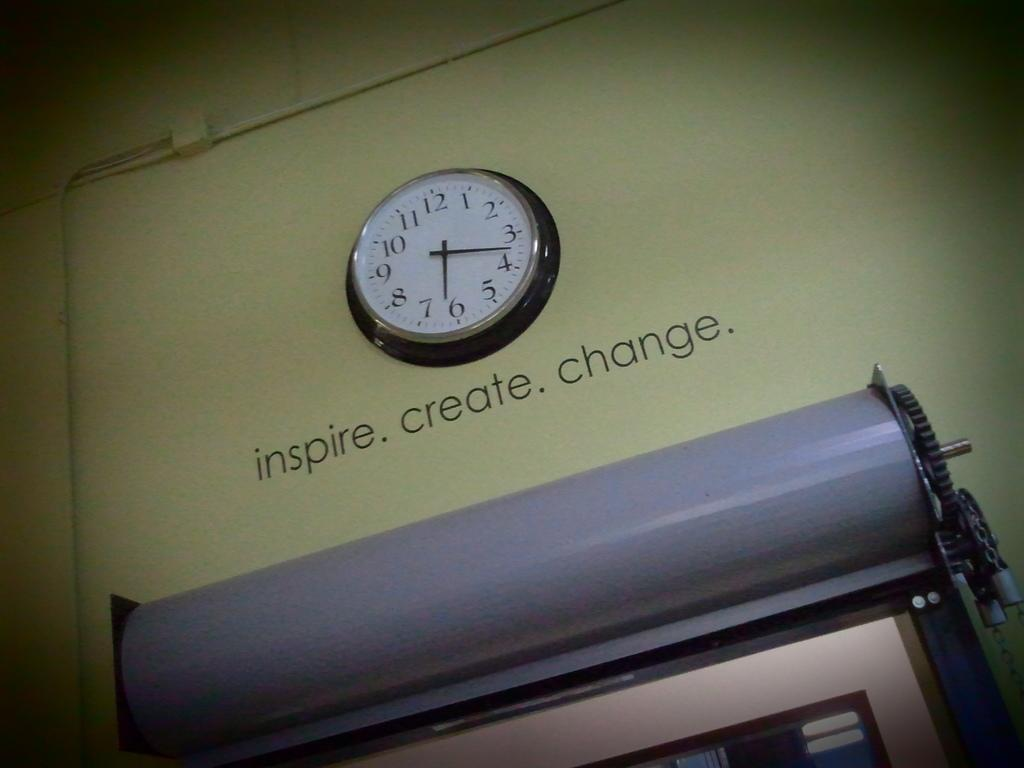What object in the image is used for measuring time? There is a clock in the image that is used for measuring time. What type of device can be seen in the image? There is a machine in the image. What can be found on the wall in the image? There is text on the wall in the image. How many tomatoes are hanging from the clock in the image? There are no tomatoes present in the image, and they are not hanging from the clock. Can you see a snake slithering across the machine in the image? There is no snake present in the image; it only features a clock, a machine, and text on the wall. 